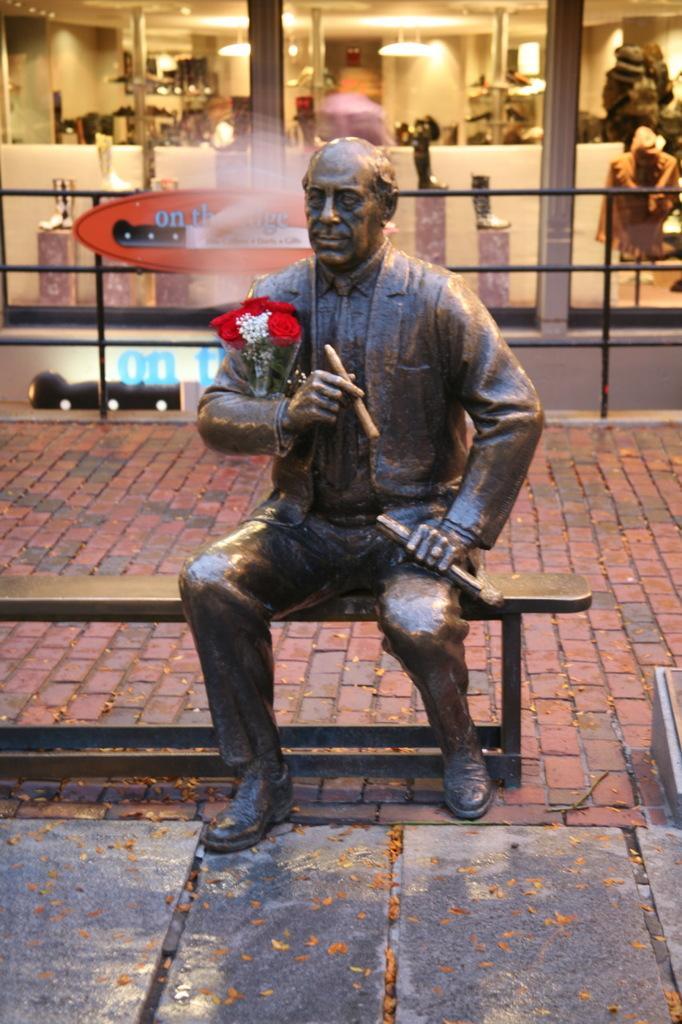In one or two sentences, can you explain what this image depicts? There is a person's statue holding a buckeye and an object with one hand an object with other hand and sitting on a bench, which is on the footpath. In the background, there is a building which is having glass windows, near a fencing. Through the glass windows, we can see, there are lights attached to the roof, there are objects on the stands and there are other objects. 